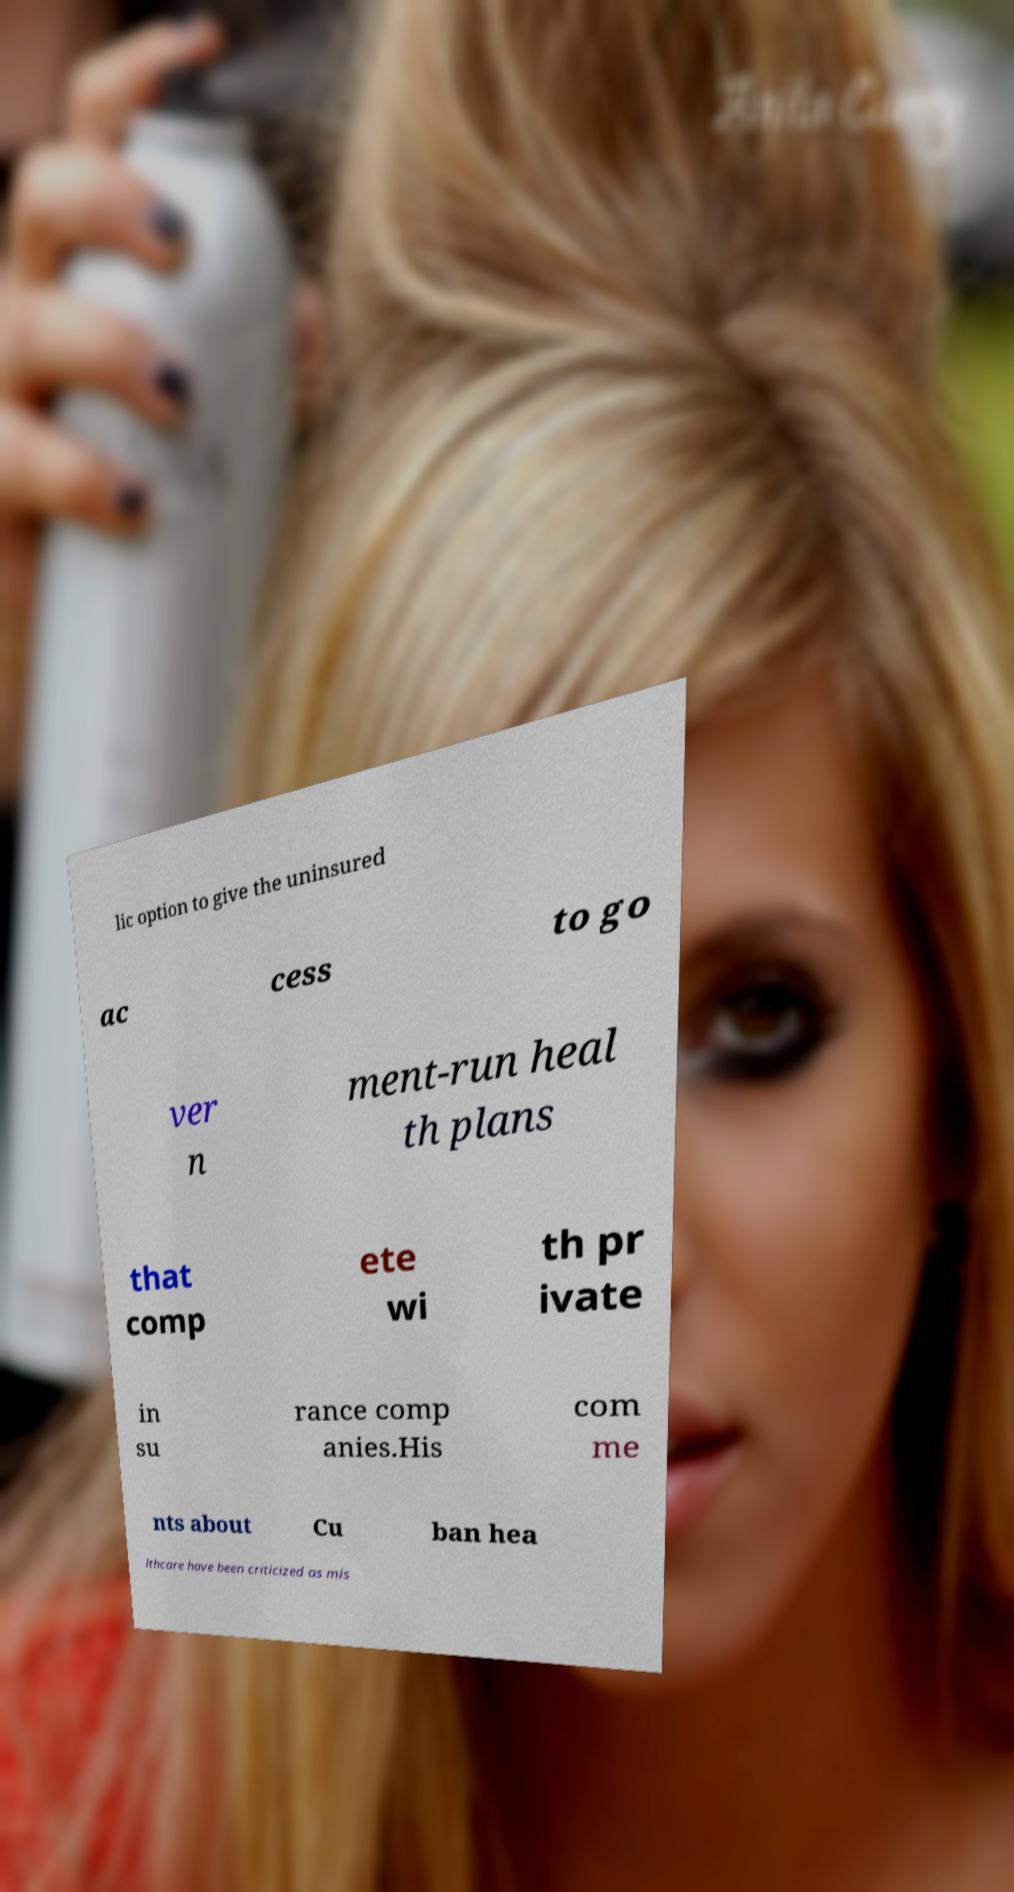Could you extract and type out the text from this image? lic option to give the uninsured ac cess to go ver n ment-run heal th plans that comp ete wi th pr ivate in su rance comp anies.His com me nts about Cu ban hea lthcare have been criticized as mis 